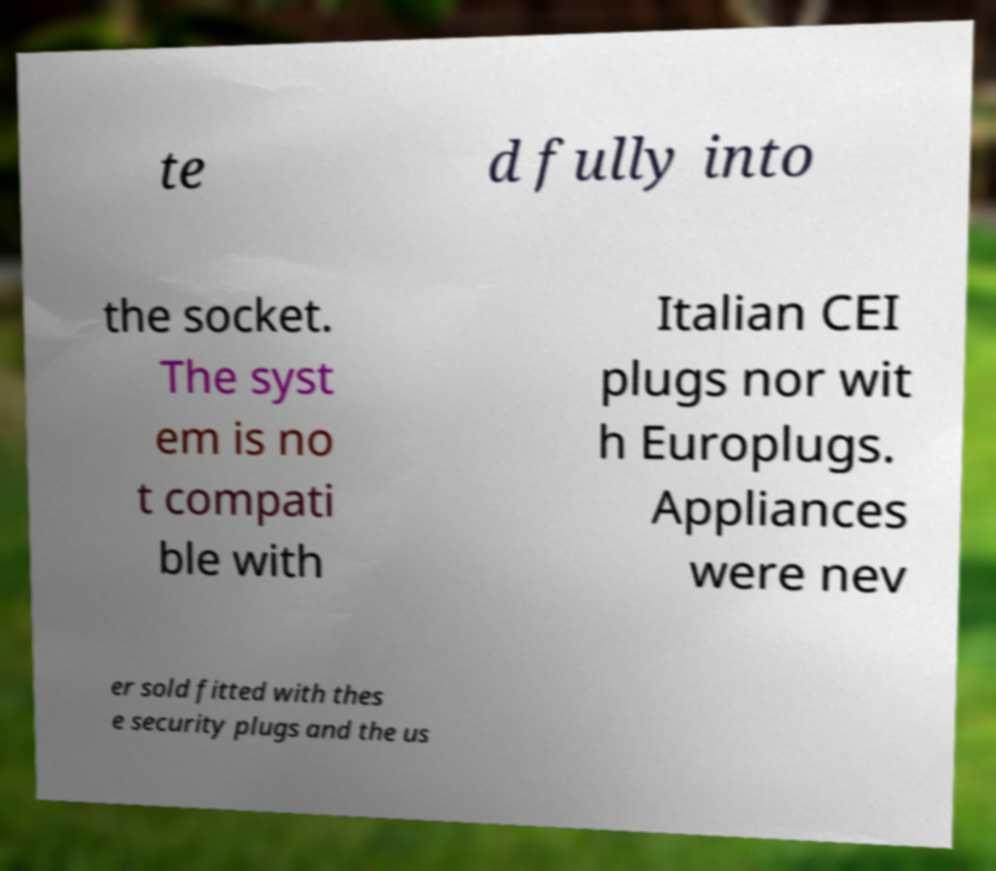Please read and relay the text visible in this image. What does it say? te d fully into the socket. The syst em is no t compati ble with Italian CEI plugs nor wit h Europlugs. Appliances were nev er sold fitted with thes e security plugs and the us 